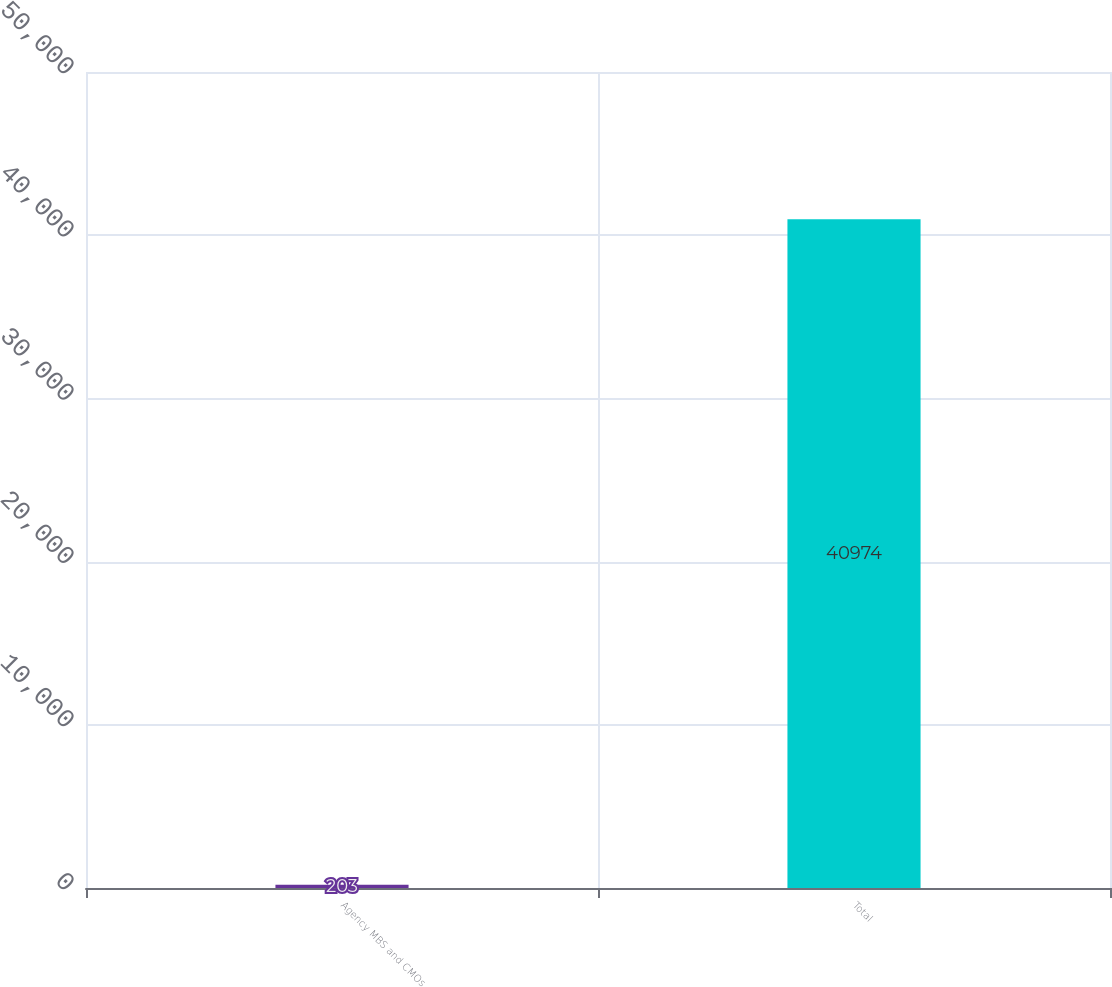Convert chart. <chart><loc_0><loc_0><loc_500><loc_500><bar_chart><fcel>Agency MBS and CMOs<fcel>Total<nl><fcel>203<fcel>40974<nl></chart> 